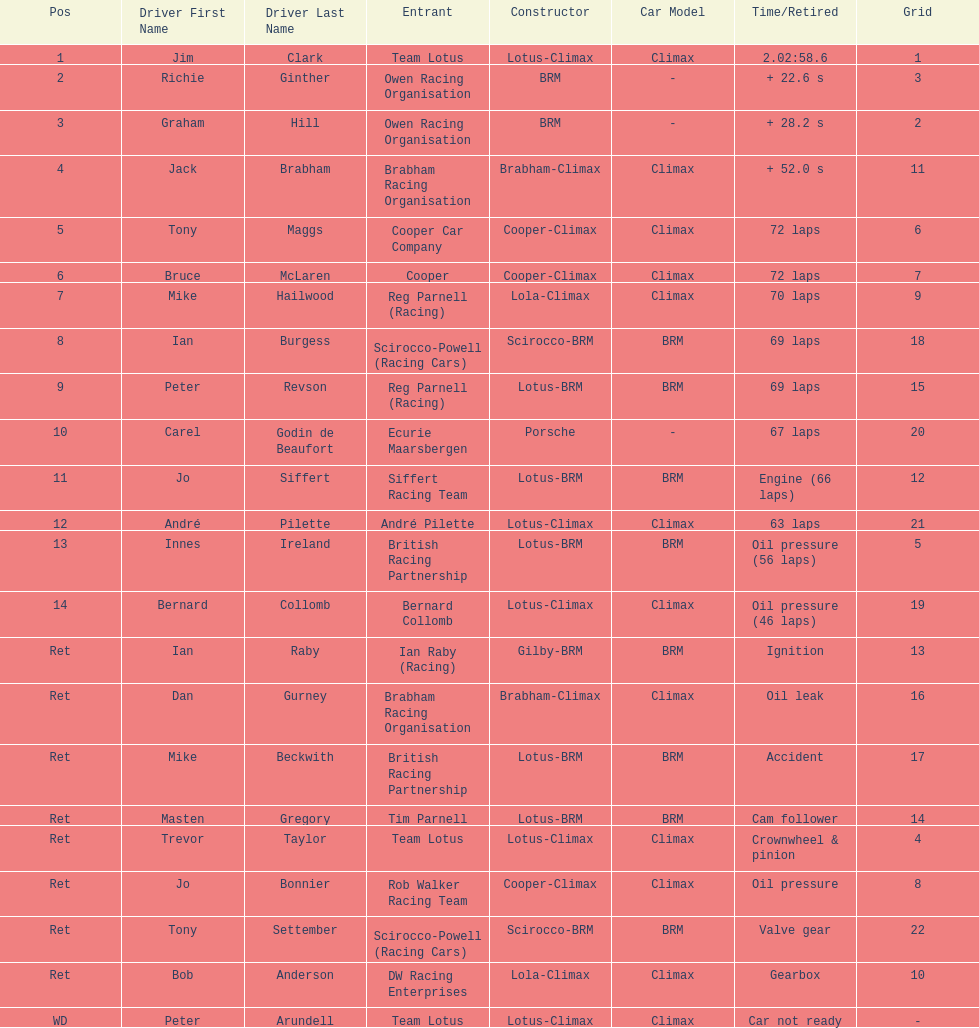What was the same problem that bernard collomb had as innes ireland? Oil pressure. 